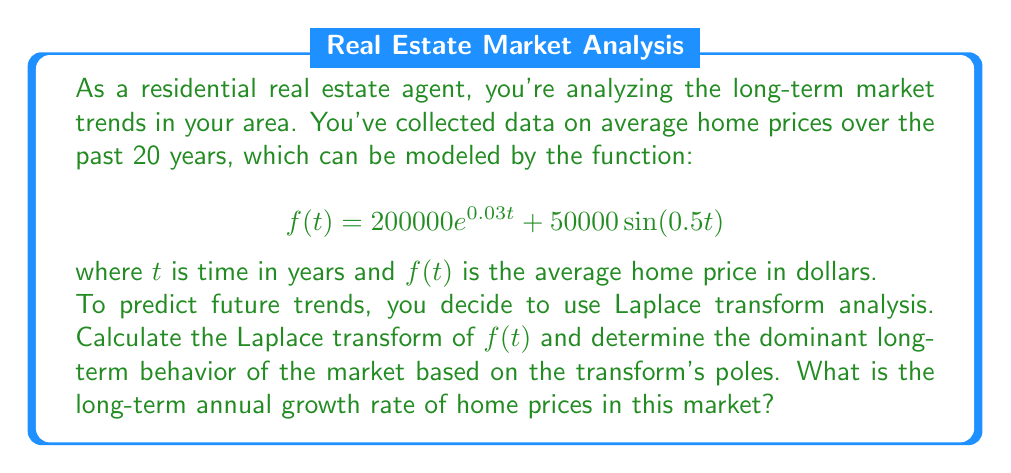Can you solve this math problem? Let's approach this step-by-step:

1) First, we need to calculate the Laplace transform of $f(t)$. The Laplace transform is defined as:

   $$F(s) = \mathcal{L}\{f(t)\} = \int_0^\infty e^{-st}f(t)dt$$

2) We can split this into two parts:
   
   $$F(s) = \mathcal{L}\{200000e^{0.03t}\} + \mathcal{L}\{50000\sin(0.5t)\}$$

3) For the first part, we use the Laplace transform of $e^{at}$:
   
   $$\mathcal{L}\{e^{at}\} = \frac{1}{s-a}$$

   So, $$\mathcal{L}\{200000e^{0.03t}\} = \frac{200000}{s-0.03}$$

4) For the second part, we use the Laplace transform of $\sin(at)$:
   
   $$\mathcal{L}\{\sin(at)\} = \frac{a}{s^2+a^2}$$

   So, $$\mathcal{L}\{50000\sin(0.5t)\} = \frac{25000}{s^2+0.25}$$

5) Combining these:

   $$F(s) = \frac{200000}{s-0.03} + \frac{25000}{s^2+0.25}$$

6) The poles of this transform are at $s=0.03$ and $s=\pm 0.5i$. The dominant long-term behavior is determined by the rightmost pole, which is at $s=0.03$.

7) The real part of this pole (0.03) represents the long-term exponential growth rate of the function.

8) To convert this to an annual percentage growth rate, we multiply by 100:

   $0.03 * 100 = 3\%$

Therefore, the long-term annual growth rate of home prices in this market is 3%.
Answer: 3% 